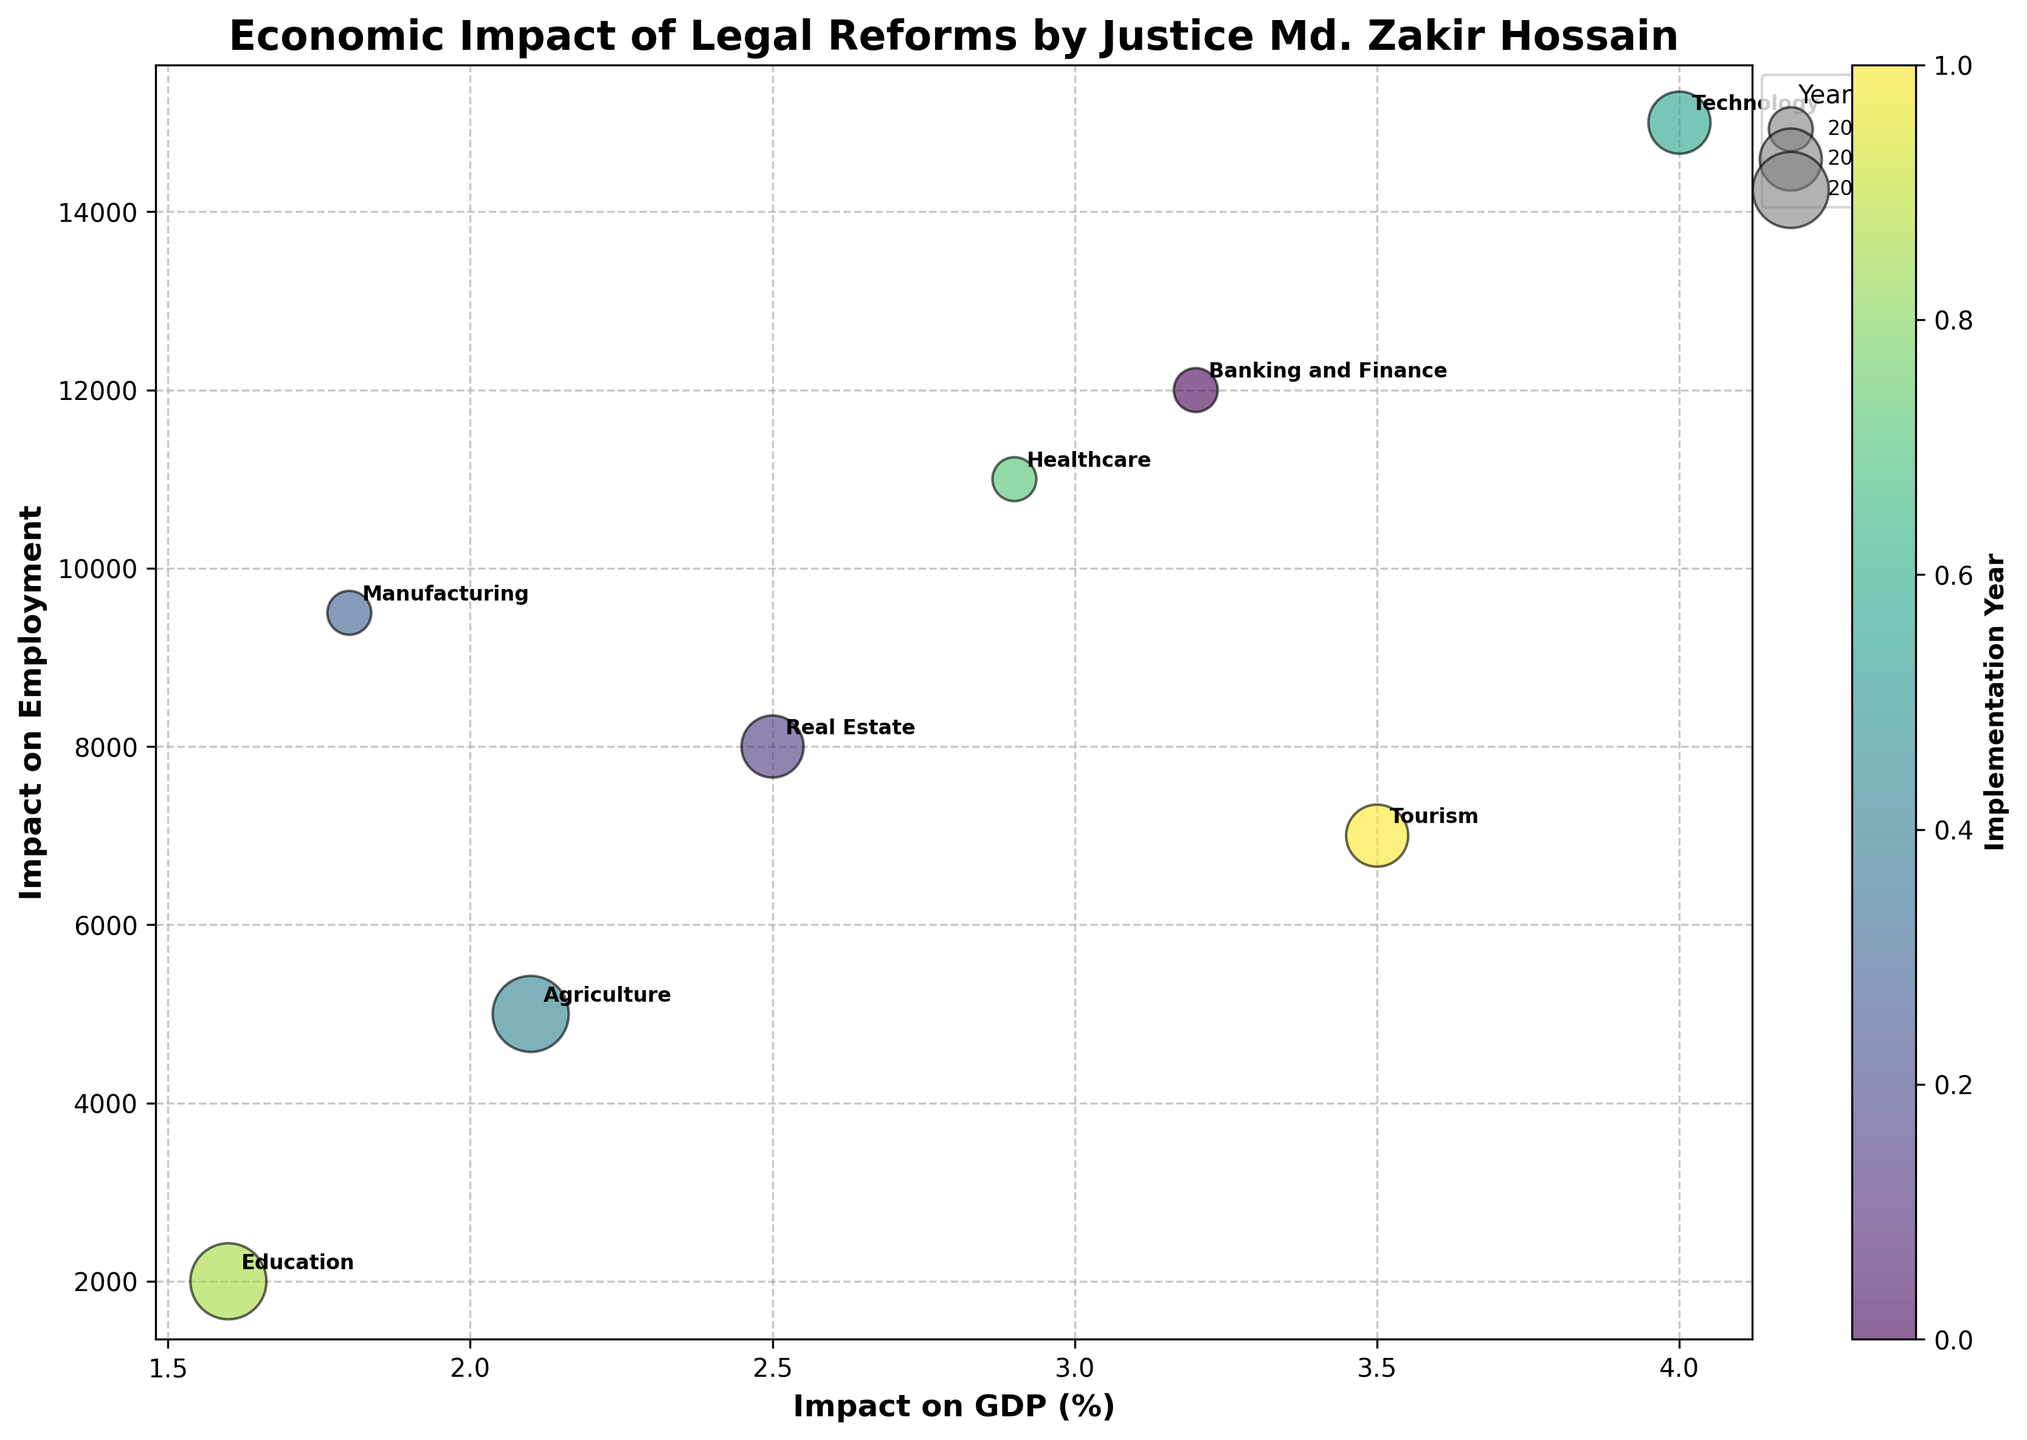How many sectors are depicted in the figure? The figure annotates each bubble, clearly representing eight distinct sectors.
Answer: Eight Which sector was impacted the most in terms of GDP? Looking at the x-axis, the Technology sector has the highest value for 'Impact on GDP' at 4.0%.
Answer: Technology What is the relationship between 'Impact on Employment' and the 'Year Implemented' size of bubbles? Larger bubbles indicate reforms implemented later. Compare the size of bubbles against 'Impact on Employment'. The largest bubbles (years 2018 or 2019) are dispersed across the y-axis with various employment impacts.
Answer: Larger bubbles correlate to later years, but their position on the y-axis varies Which sectors have reforms implemented in 2017? The legend and bubble sizes combined with data annotations show that Banking and Finance, Manufacturing, and Healthcare sectors have reforms implemented in 2017.
Answer: Banking and Finance, Manufacturing, Healthcare What is the average 'Impact on GDP' for the sectors? Sum the GDP impacts: 3.2 + 2.5 + 1.8 + 2.1 + 4.0 + 2.9 + 1.6 + 3.5 to get 21.6. Divide by the number of sectors, 8, to get 2.7%.
Answer: 2.7% Which sector has the highest 'Impact on Employment'? By assessing the y-axis, the Technology sector has the highest 'Impact on Employment' with 15,000.
Answer: Technology How do the ‘Impact on GDP’ and ‘Impact on Employment’ compare for the Banking and Finance sector with Real Estate? The Banking and Finance sector has an 'Impact on GDP' of 3.2 and 'Impact on Employment' of 12,000; Real Estate has 2.5 and 8,000. Compare each pair respectively.
Answer: Banking and Finance > Real Estate for both GDP and employment What is the range of years in which the reforms were implemented? Bubbles represent years 2017 to 2019. The legend and bubble sizes assist in identifying this range.
Answer: 2017-2019 What sector had the lowest impact on employment? By examining the y-axis, the Education sector has the lowest 'Impact on Employment' with 2000.
Answer: Education 